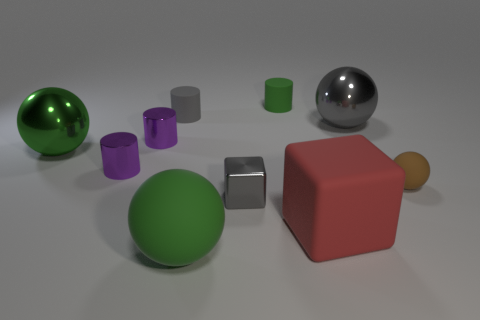There is a small cylinder that is the same color as the large rubber ball; what is it made of?
Offer a terse response. Rubber. Are there any tiny things that have the same color as the small block?
Ensure brevity in your answer.  Yes. Are there an equal number of big cubes that are in front of the small cube and small cubes left of the large gray metallic thing?
Your answer should be very brief. Yes. There is a green object that is the same shape as the gray matte object; what is its material?
Your response must be concise. Rubber. Is there a tiny cylinder that is in front of the small gray thing behind the large metallic thing behind the large green metal object?
Provide a short and direct response. Yes. There is a thing that is on the right side of the gray metal ball; is it the same shape as the gray object that is right of the gray metal cube?
Your answer should be very brief. Yes. Is the number of gray things that are in front of the tiny brown matte object greater than the number of large gray rubber cubes?
Your response must be concise. Yes. How many things are either purple objects or rubber cylinders?
Your answer should be compact. 4. What color is the large rubber sphere?
Your answer should be compact. Green. How many other objects are there of the same color as the small rubber ball?
Your answer should be compact. 0. 